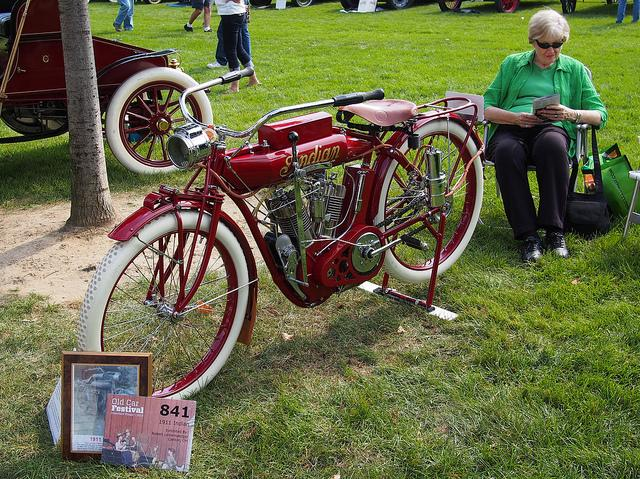For what purpose is this bike being exhibited? collectable 